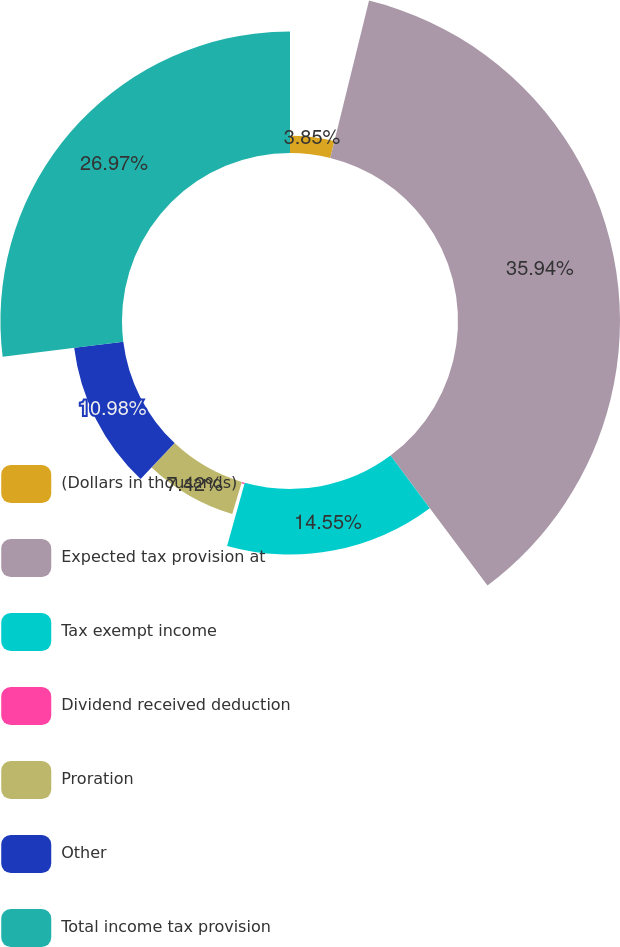Convert chart. <chart><loc_0><loc_0><loc_500><loc_500><pie_chart><fcel>(Dollars in thousands)<fcel>Expected tax provision at<fcel>Tax exempt income<fcel>Dividend received deduction<fcel>Proration<fcel>Other<fcel>Total income tax provision<nl><fcel>3.85%<fcel>35.94%<fcel>14.55%<fcel>0.29%<fcel>7.42%<fcel>10.98%<fcel>26.97%<nl></chart> 